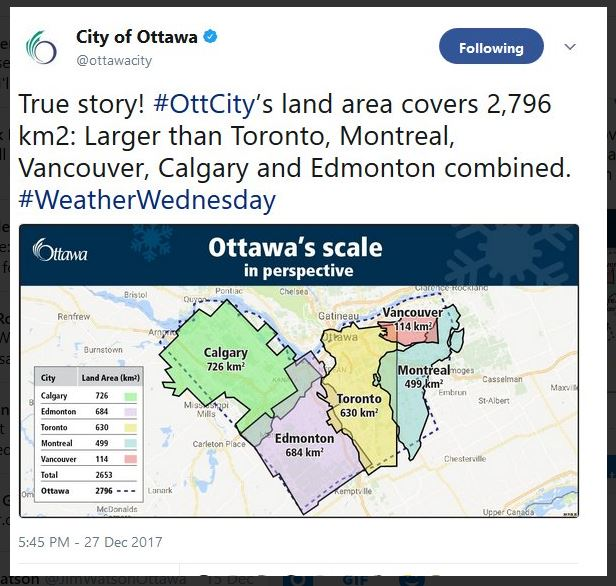What are some implications of Ottawa having a larger land area than these major Canadian cities combined? Ottawa's larger land area could have several implications. It means the city has more space for infrastructure, parks, and potentially less population density in certain areas compared to the other cities. The extensive land area can allow for broader urban planning initiatives, development of eco-friendly zones, and better distribution of services. It also might imply higher costs in maintaining infrastructure spread over a larger area, and possibly greater variation in land use, with significant portions dedicated to green spaces or rural land. 